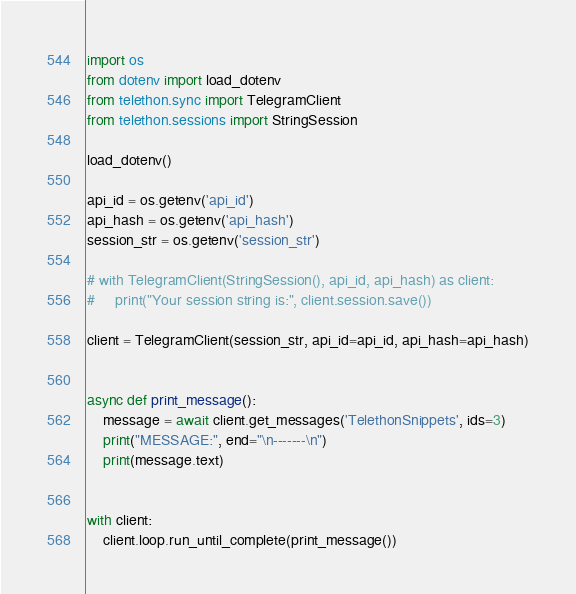<code> <loc_0><loc_0><loc_500><loc_500><_Python_>import os
from dotenv import load_dotenv
from telethon.sync import TelegramClient
from telethon.sessions import StringSession

load_dotenv()

api_id = os.getenv('api_id')
api_hash = os.getenv('api_hash')
session_str = os.getenv('session_str')

# with TelegramClient(StringSession(), api_id, api_hash) as client:
#     print("Your session string is:", client.session.save())

client = TelegramClient(session_str, api_id=api_id, api_hash=api_hash)


async def print_message():
    message = await client.get_messages('TelethonSnippets', ids=3)
    print("MESSAGE:", end="\n-------\n")
    print(message.text)


with client:
    client.loop.run_until_complete(print_message())
</code> 